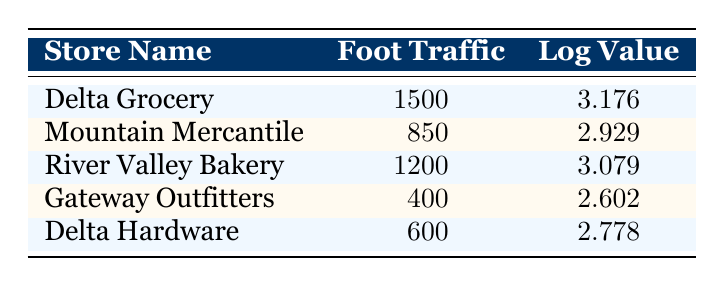What is the foot traffic count for Delta Grocery? The table directly lists the foot traffic count for Delta Grocery as 1500.
Answer: 1500 What is the logarithmic value for River Valley Bakery? The table states the logarithmic value for River Valley Bakery is 3.079.
Answer: 3.079 Which store has the highest foot traffic count? Looking at the foot traffic counts in the table, Delta Grocery has the highest count at 1500.
Answer: Delta Grocery Is the foot traffic count for Gateway Outfitters greater than Delta Hardware? The table shows Gateway Outfitters has a count of 400 and Delta Hardware has 600, meaning Gateway Outfitters has less foot traffic.
Answer: No What is the average foot traffic count for all the stores listed? To find the average, add all the foot traffic counts: 1500 + 850 + 1200 + 400 + 600 = 3550. There are 5 stores, so the average is 3550/5 = 710.
Answer: 710 Which store has a logarithmic value closest to 3.0? Comparing the logarithmic values, Mountain Mercantile has the closest value at 2.929.
Answer: Mountain Mercantile If we consider both the foot traffic count and logarithmic values, how many stores have a foot traffic count above 1000? By checking the foot traffic counts, only Delta Grocery (1500) and River Valley Bakery (1200) are above 1000, making it 2 stores in total.
Answer: 2 Is there a store with a foot traffic count of exactly 600? The table indicates that Delta Hardware has a foot traffic count of 600.
Answer: Yes What is the difference in foot traffic between Delta Grocery and Gateway Outfitters? Delta Grocery's count is 1500 and Gateway Outfitters' is 400. The difference is 1500 - 400 = 1100.
Answer: 1100 